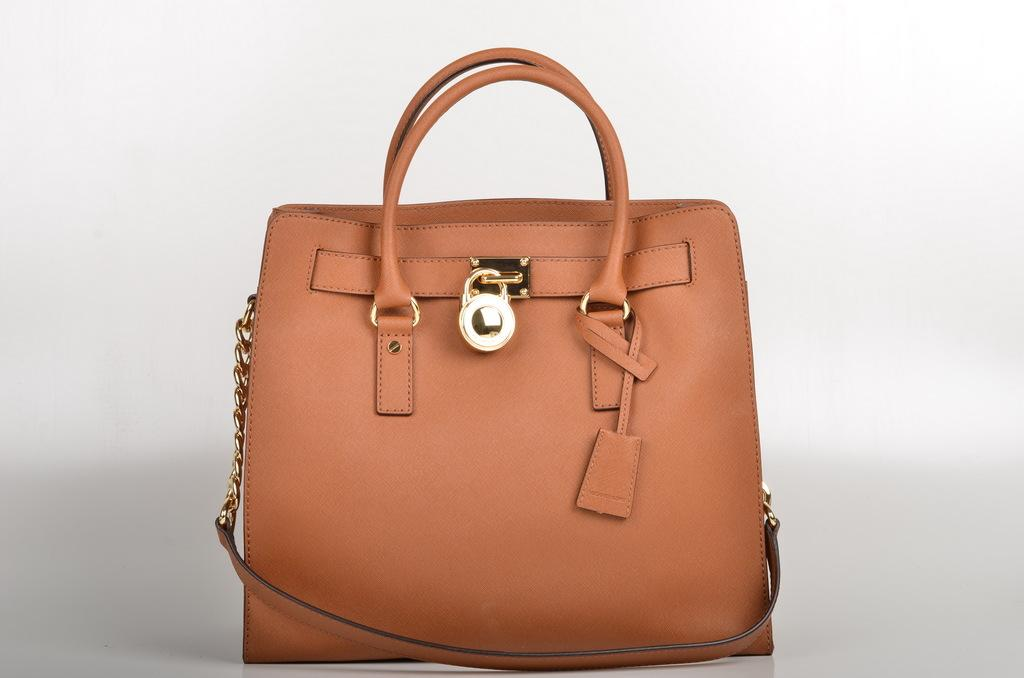What object can be seen in the image? There is a bag in the image. What is the color of the bag? The bag is brown in color. Are there any additional features on the bag? Yes, the bag has a lock in the middle and a chain on the left side. Can you see a river flowing near the bag in the image? No, there is no river present in the image. Is there a potato visible in the image? No, there is no potato present in the image. 